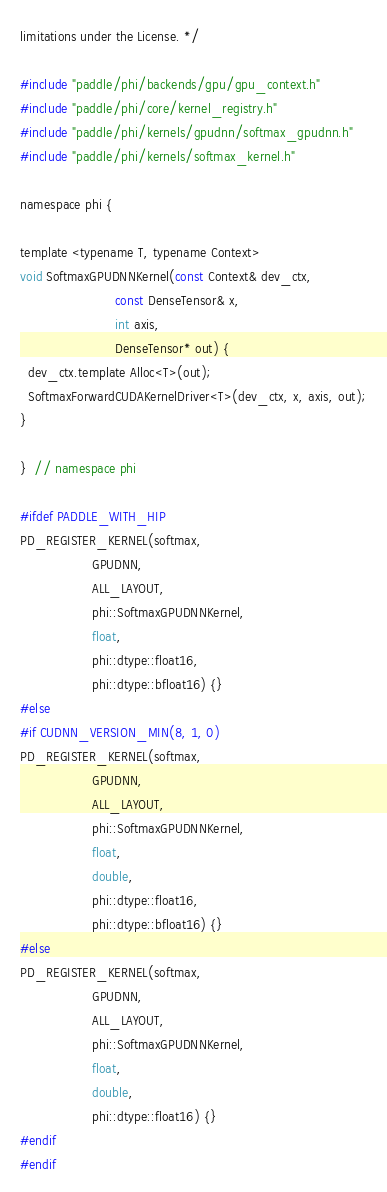Convert code to text. <code><loc_0><loc_0><loc_500><loc_500><_Cuda_>limitations under the License. */

#include "paddle/phi/backends/gpu/gpu_context.h"
#include "paddle/phi/core/kernel_registry.h"
#include "paddle/phi/kernels/gpudnn/softmax_gpudnn.h"
#include "paddle/phi/kernels/softmax_kernel.h"

namespace phi {

template <typename T, typename Context>
void SoftmaxGPUDNNKernel(const Context& dev_ctx,
                         const DenseTensor& x,
                         int axis,
                         DenseTensor* out) {
  dev_ctx.template Alloc<T>(out);
  SoftmaxForwardCUDAKernelDriver<T>(dev_ctx, x, axis, out);
}

}  // namespace phi

#ifdef PADDLE_WITH_HIP
PD_REGISTER_KERNEL(softmax,
                   GPUDNN,
                   ALL_LAYOUT,
                   phi::SoftmaxGPUDNNKernel,
                   float,
                   phi::dtype::float16,
                   phi::dtype::bfloat16) {}
#else
#if CUDNN_VERSION_MIN(8, 1, 0)
PD_REGISTER_KERNEL(softmax,
                   GPUDNN,
                   ALL_LAYOUT,
                   phi::SoftmaxGPUDNNKernel,
                   float,
                   double,
                   phi::dtype::float16,
                   phi::dtype::bfloat16) {}
#else
PD_REGISTER_KERNEL(softmax,
                   GPUDNN,
                   ALL_LAYOUT,
                   phi::SoftmaxGPUDNNKernel,
                   float,
                   double,
                   phi::dtype::float16) {}
#endif
#endif
</code> 